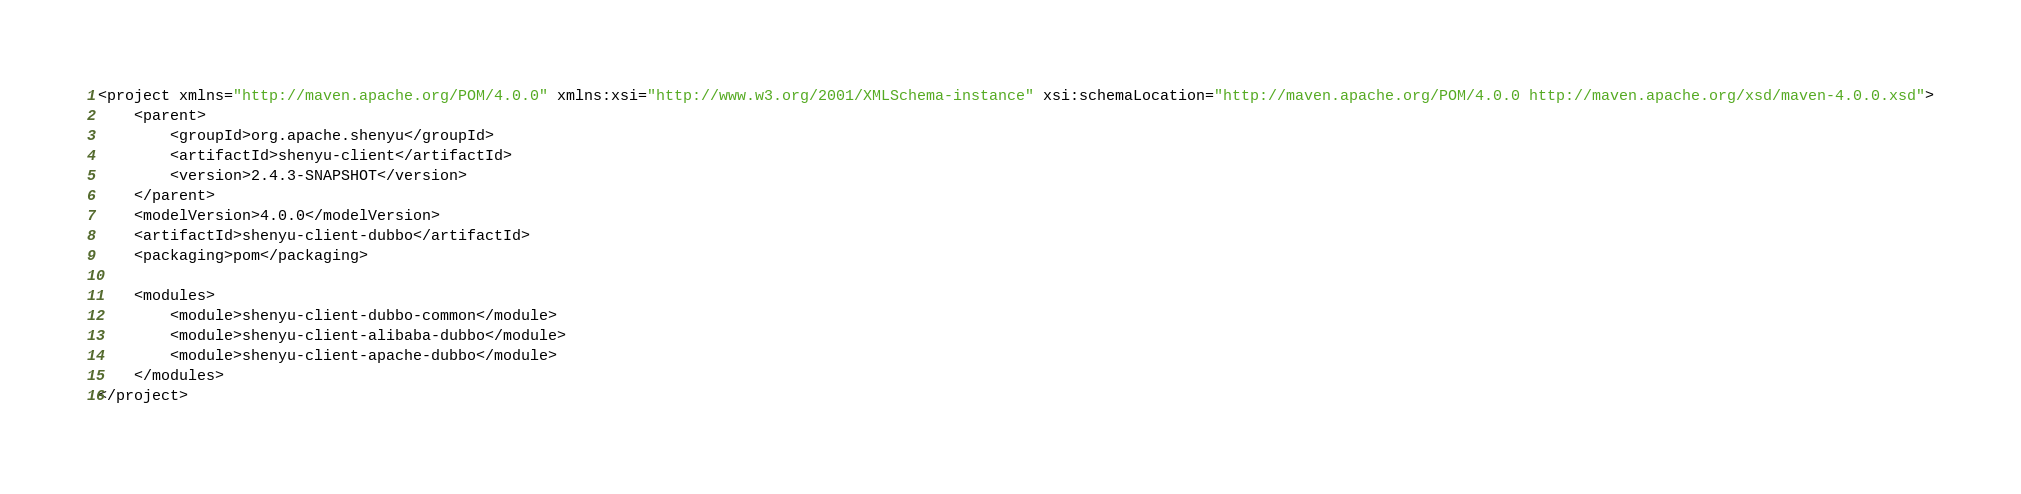<code> <loc_0><loc_0><loc_500><loc_500><_XML_>
<project xmlns="http://maven.apache.org/POM/4.0.0" xmlns:xsi="http://www.w3.org/2001/XMLSchema-instance" xsi:schemaLocation="http://maven.apache.org/POM/4.0.0 http://maven.apache.org/xsd/maven-4.0.0.xsd">
    <parent>
        <groupId>org.apache.shenyu</groupId>
        <artifactId>shenyu-client</artifactId>
        <version>2.4.3-SNAPSHOT</version>
    </parent>
    <modelVersion>4.0.0</modelVersion>
    <artifactId>shenyu-client-dubbo</artifactId>
    <packaging>pom</packaging>
    
    <modules>
        <module>shenyu-client-dubbo-common</module>
        <module>shenyu-client-alibaba-dubbo</module>
        <module>shenyu-client-apache-dubbo</module>
    </modules>
</project></code> 